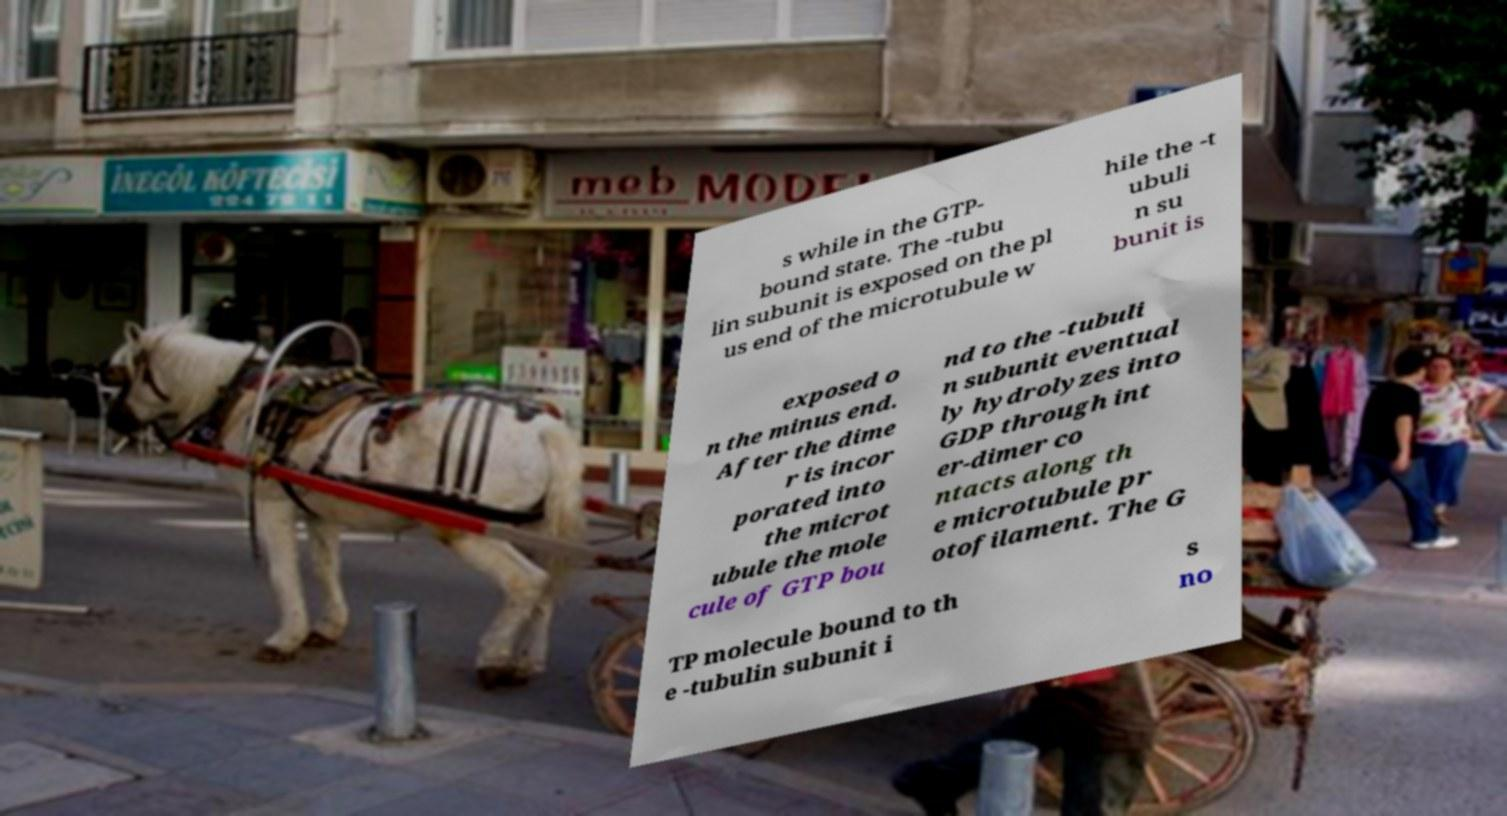Please read and relay the text visible in this image. What does it say? s while in the GTP- bound state. The -tubu lin subunit is exposed on the pl us end of the microtubule w hile the -t ubuli n su bunit is exposed o n the minus end. After the dime r is incor porated into the microt ubule the mole cule of GTP bou nd to the -tubuli n subunit eventual ly hydrolyzes into GDP through int er-dimer co ntacts along th e microtubule pr otofilament. The G TP molecule bound to th e -tubulin subunit i s no 